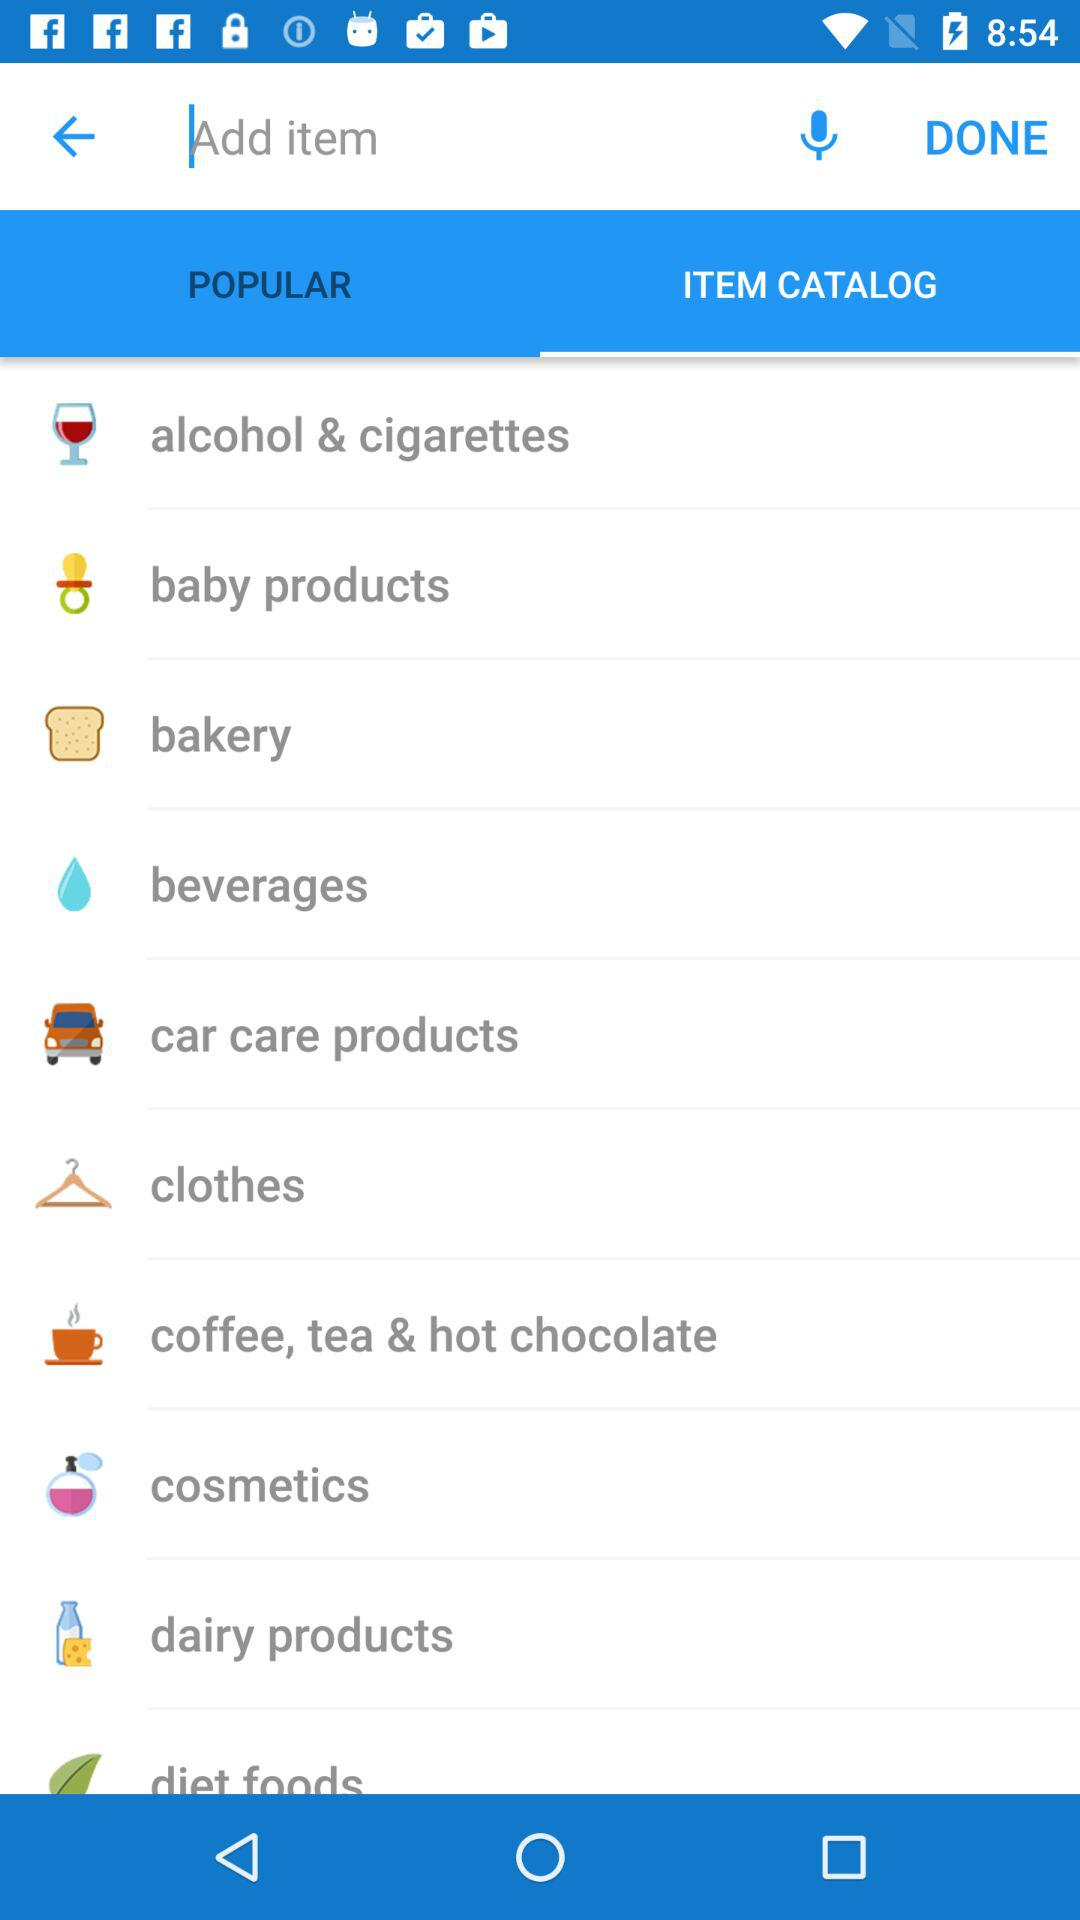Which tab has been selected? The tab that has been selected is "ITEM CATALOG". 